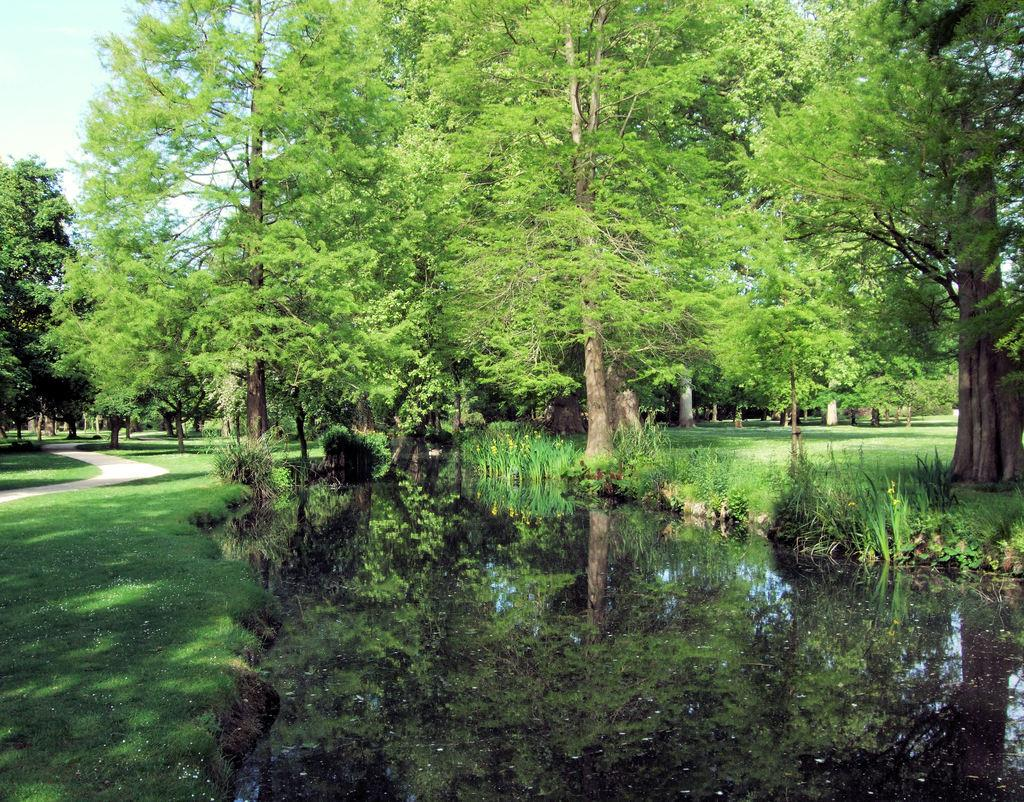What type of natural environment is depicted in the image? The image contains a lot of greenery, including grass, trees, and plants. Can you describe the path visible in the image? There is a path on the left side of the image. What part of the natural environment is visible in the image? The sky is visible in the image. What type of stamp can be seen on the tree in the image? There is no stamp present on the tree in the image. What type of tooth is visible in the image? There is no tooth visible in the image. 